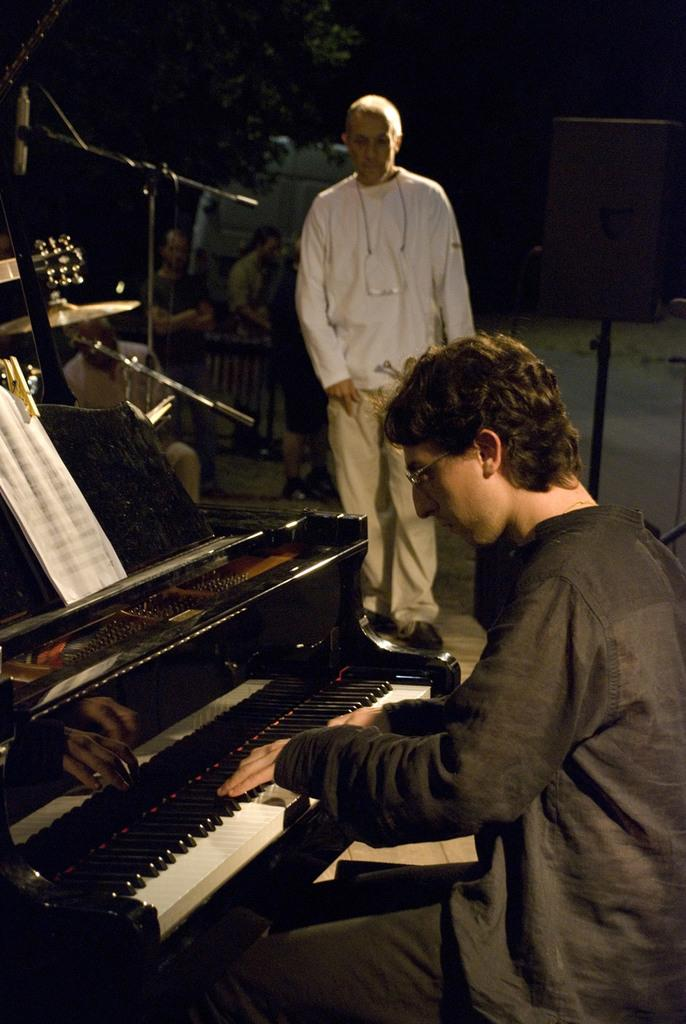What is the main subject of the image? There is a man playing a piano in the image. Can you describe the other person in the image? There is another man standing on the floor in the image. What color is the shirt worn by the dust in the image? There is no dust present in the image, and therefore no shirt can be associated with it. 